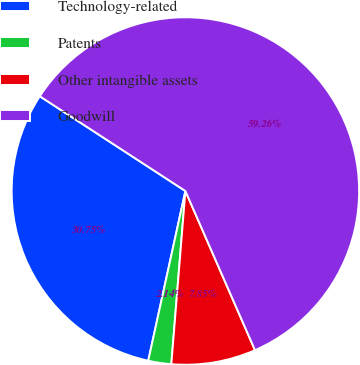Convert chart. <chart><loc_0><loc_0><loc_500><loc_500><pie_chart><fcel>Technology-related<fcel>Patents<fcel>Other intangible assets<fcel>Goodwill<nl><fcel>30.75%<fcel>2.14%<fcel>7.85%<fcel>59.25%<nl></chart> 